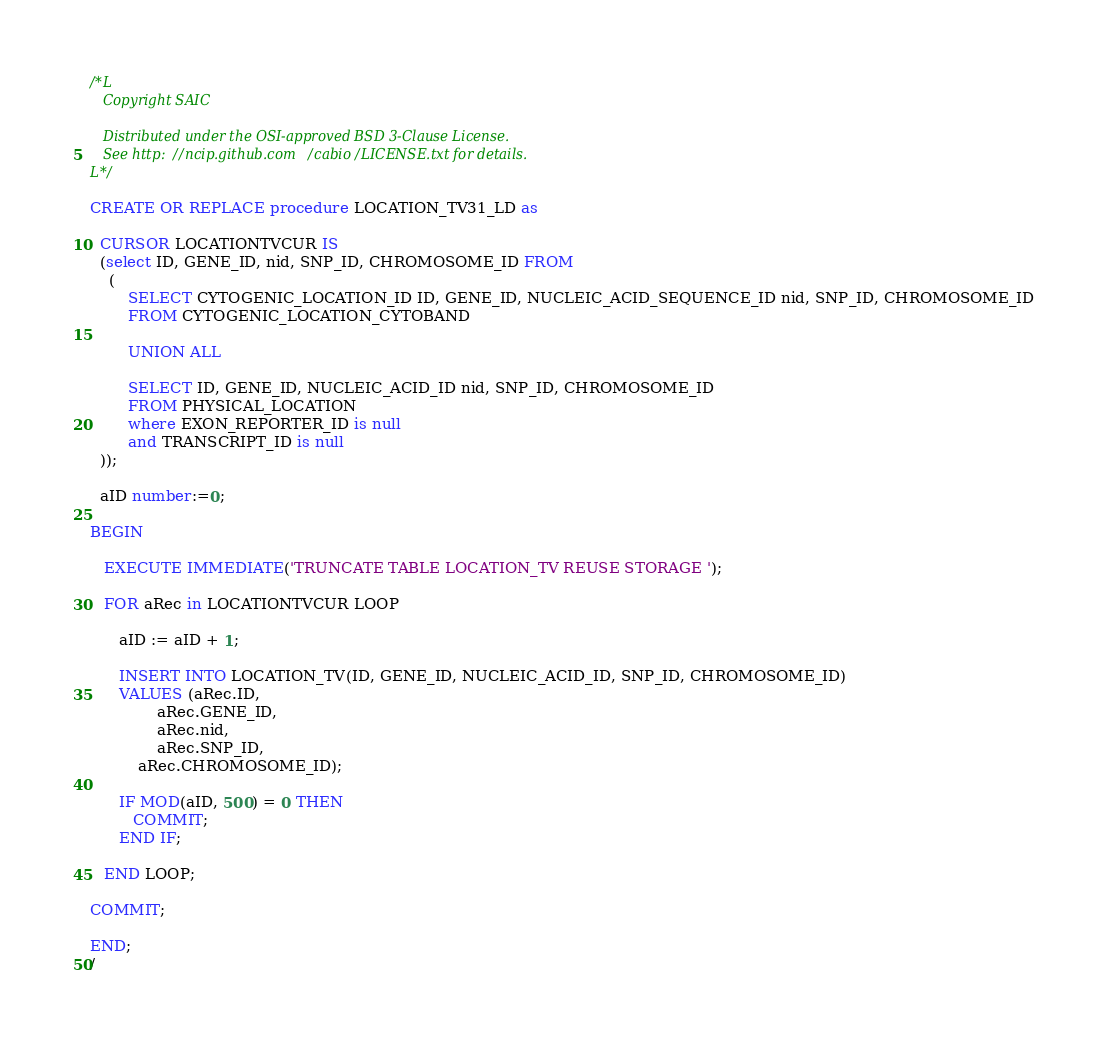<code> <loc_0><loc_0><loc_500><loc_500><_SQL_>/*L
   Copyright SAIC

   Distributed under the OSI-approved BSD 3-Clause License.
   See http://ncip.github.com/cabio/LICENSE.txt for details.
L*/

CREATE OR REPLACE procedure LOCATION_TV31_LD as

  CURSOR LOCATIONTVCUR IS
  (select ID, GENE_ID, nid, SNP_ID, CHROMOSOME_ID FROM
	(
		SELECT CYTOGENIC_LOCATION_ID ID, GENE_ID, NUCLEIC_ACID_SEQUENCE_ID nid, SNP_ID, CHROMOSOME_ID
	 	FROM CYTOGENIC_LOCATION_CYTOBAND
	 	
 		UNION ALL
 		
 		SELECT ID, GENE_ID, NUCLEIC_ACID_ID nid, SNP_ID, CHROMOSOME_ID
 		FROM PHYSICAL_LOCATION
 		where EXON_REPORTER_ID is null 
 		and TRANSCRIPT_ID is null
  ));

  aID number:=0;

BEGIN

   EXECUTE IMMEDIATE('TRUNCATE TABLE LOCATION_TV REUSE STORAGE ');

   FOR aRec in LOCATIONTVCUR LOOP

      aID := aID + 1;

      INSERT INTO LOCATION_TV(ID, GENE_ID, NUCLEIC_ACID_ID, SNP_ID, CHROMOSOME_ID)
      VALUES (aRec.ID,
              aRec.GENE_ID,
              aRec.nid,
              aRec.SNP_ID,
	      aRec.CHROMOSOME_ID);

      IF MOD(aID, 500) = 0 THEN
         COMMIT;
      END IF;

   END LOOP;

COMMIT;

END; 
/

</code> 